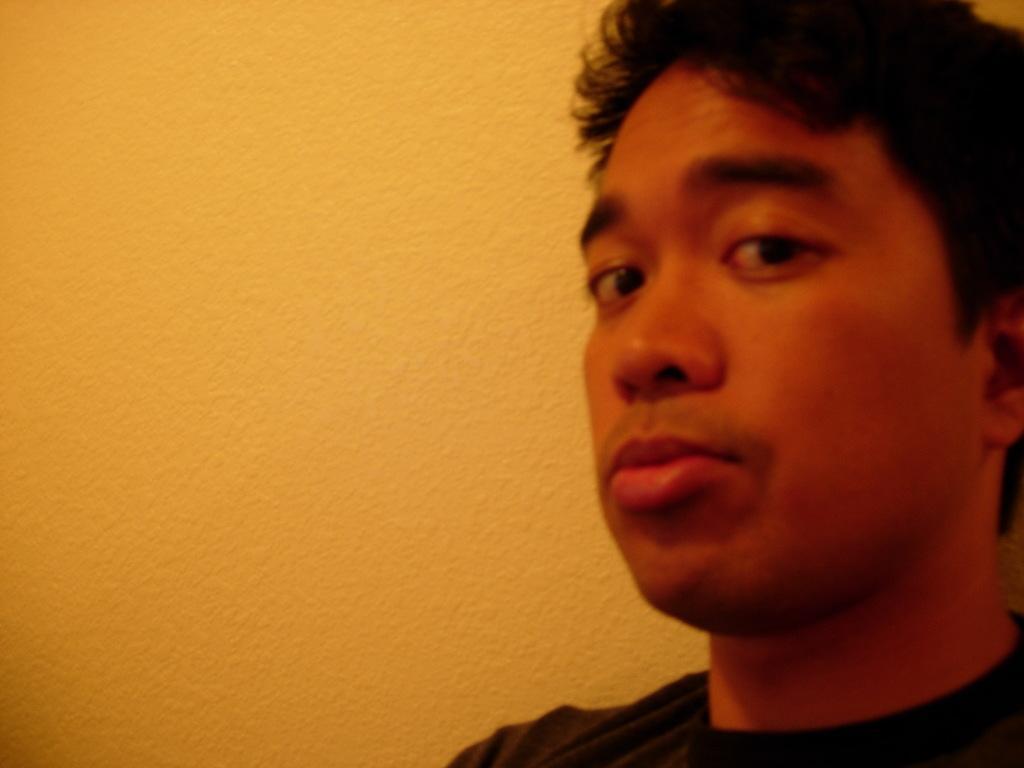Can you describe this image briefly? In this picture we can see a man and in the background we can see the wall. 